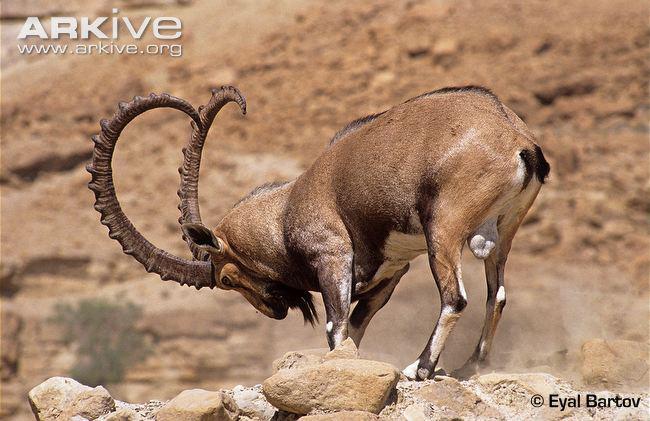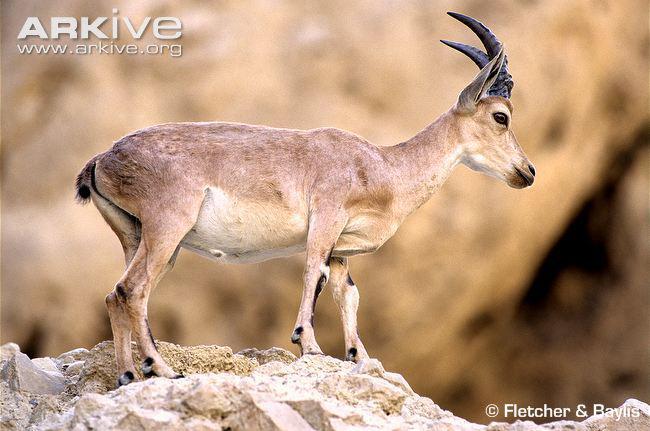The first image is the image on the left, the second image is the image on the right. Analyze the images presented: Is the assertion "The left image contains a bigger horned animal and at least one smaller animal without a set of prominent horns." valid? Answer yes or no. No. 